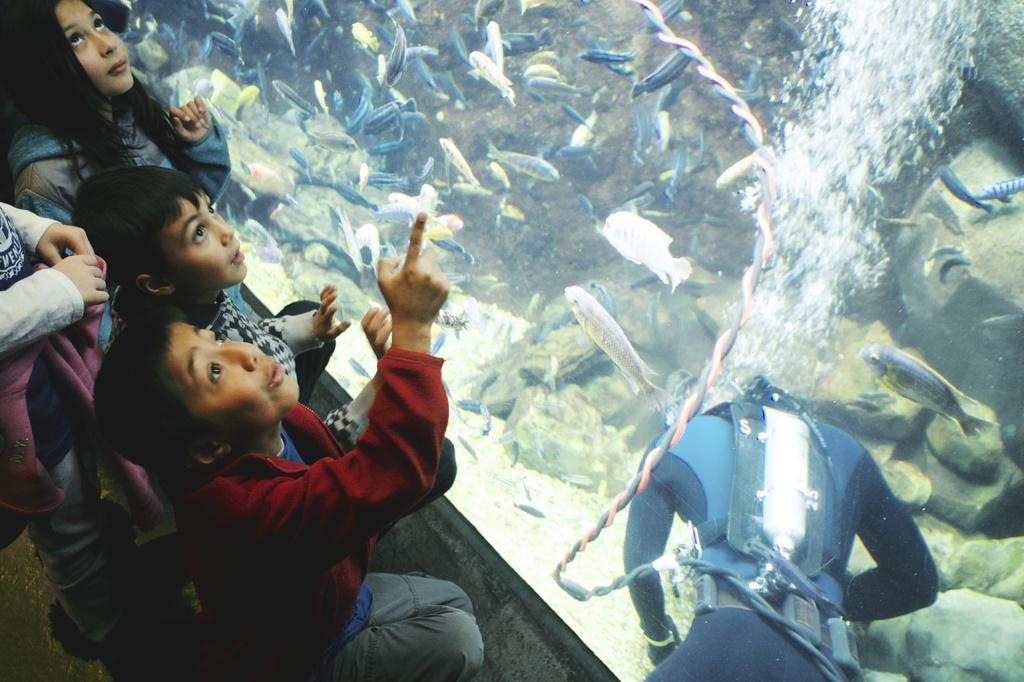What is the main subject of the image? The main subject of the image is an aquarium. What can be found inside the aquarium? There is water and fishes inside the aquarium. What is the person with a wire doing in the image? The person with a wire is likely involved in maintaining or operating the aquarium. Who else can be seen in the image? Children are present beside the aquarium. What type of creature can be seen in the aftermath of the image? There is no aftermath mentioned in the image, and no creature is present. How many hens are visible in the image? There are no hens present in the image. 